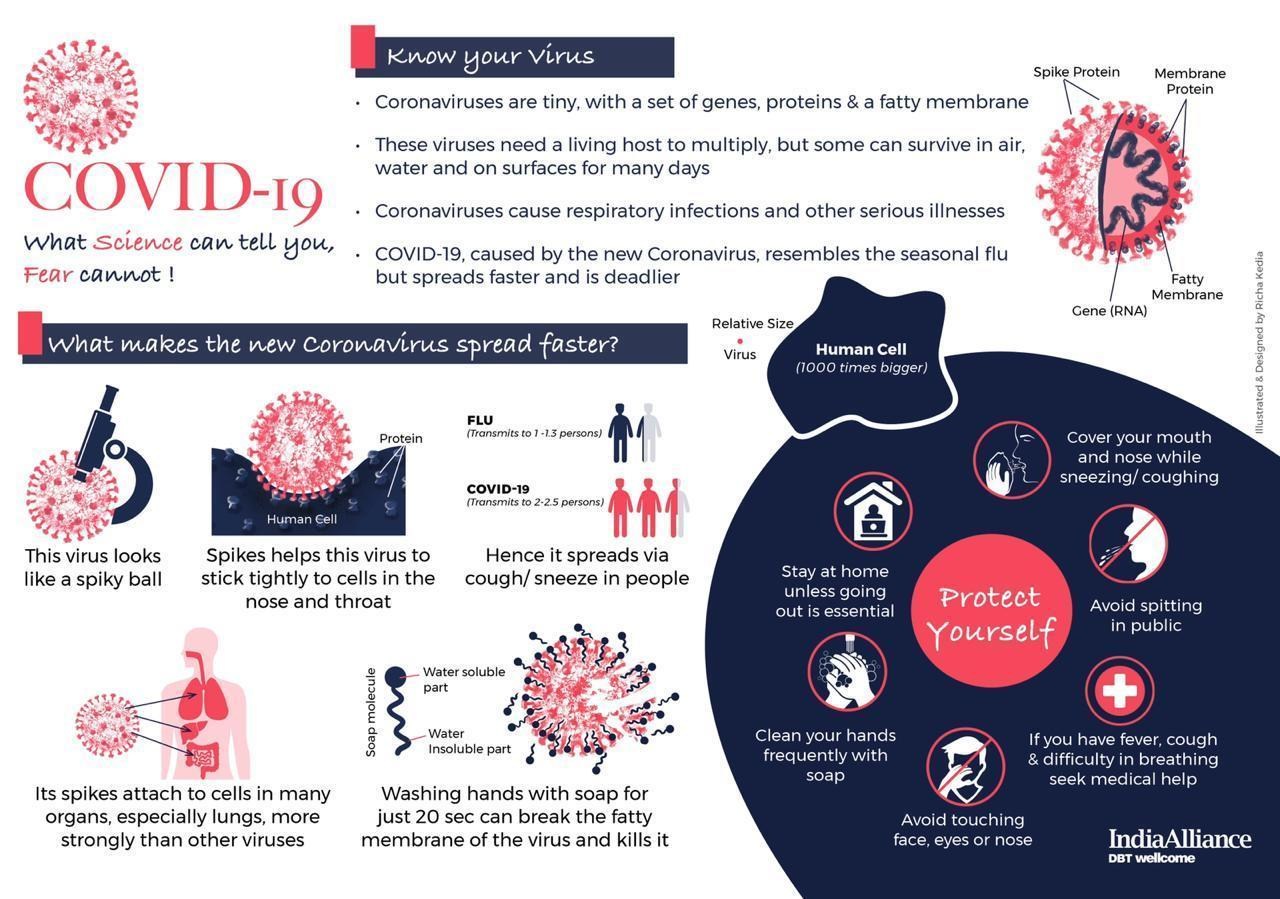How many points are given under the topic "know your virus"?
Answer the question with a short phrase. 4 what is the point given at the top side of the topic "protect yourself"? cover your mouth and nose while sneezing/ coughing what is the third point given under the topic "know your virus"? coronaviruses cause respiratory infections and other serious illnesses what is the point given at the bottom side of the topic "protect yourself"? avoid touching face, eyes or nose How many points are given around the topic "protect yourself"? 6 